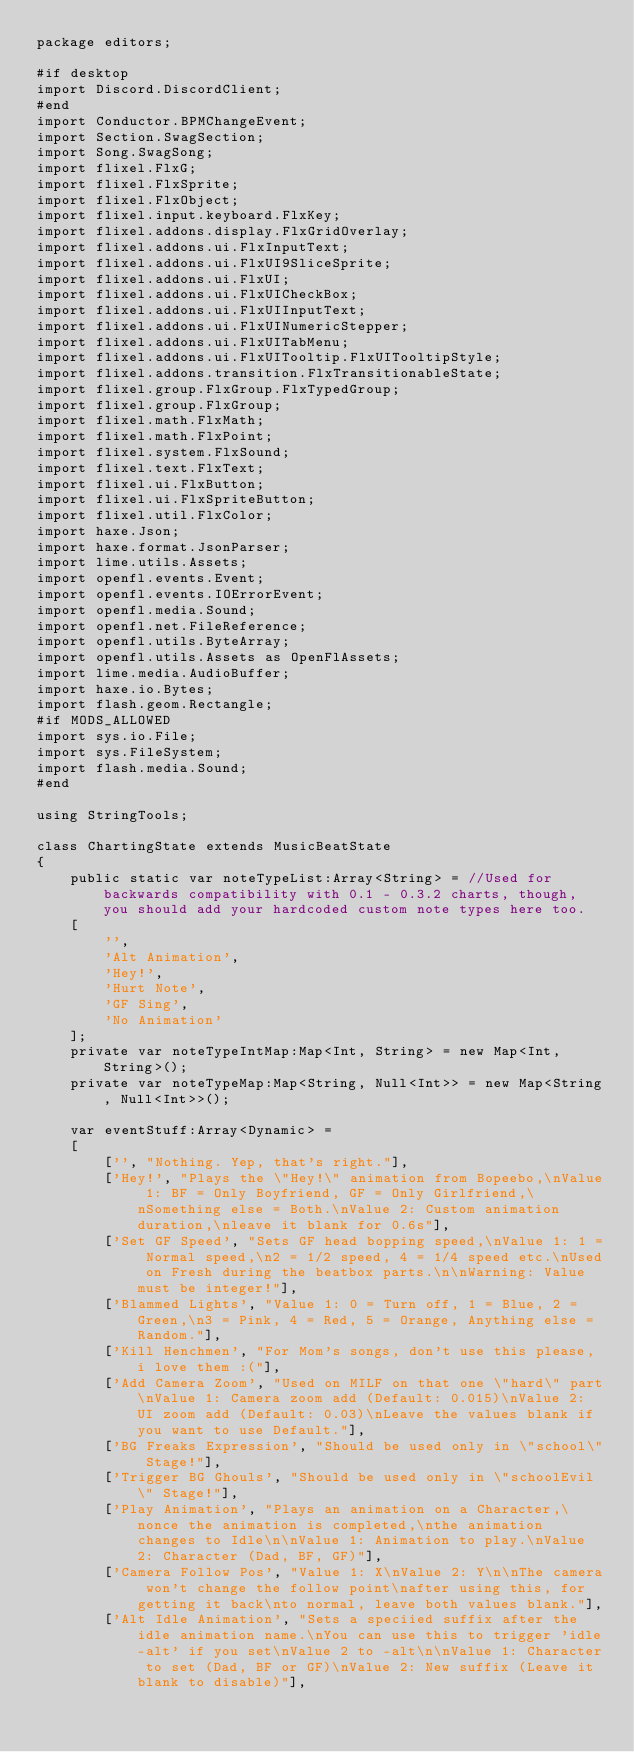<code> <loc_0><loc_0><loc_500><loc_500><_Haxe_>package editors;

#if desktop
import Discord.DiscordClient;
#end
import Conductor.BPMChangeEvent;
import Section.SwagSection;
import Song.SwagSong;
import flixel.FlxG;
import flixel.FlxSprite;
import flixel.FlxObject;
import flixel.input.keyboard.FlxKey;
import flixel.addons.display.FlxGridOverlay;
import flixel.addons.ui.FlxInputText;
import flixel.addons.ui.FlxUI9SliceSprite;
import flixel.addons.ui.FlxUI;
import flixel.addons.ui.FlxUICheckBox;
import flixel.addons.ui.FlxUIInputText;
import flixel.addons.ui.FlxUINumericStepper;
import flixel.addons.ui.FlxUITabMenu;
import flixel.addons.ui.FlxUITooltip.FlxUITooltipStyle;
import flixel.addons.transition.FlxTransitionableState;
import flixel.group.FlxGroup.FlxTypedGroup;
import flixel.group.FlxGroup;
import flixel.math.FlxMath;
import flixel.math.FlxPoint;
import flixel.system.FlxSound;
import flixel.text.FlxText;
import flixel.ui.FlxButton;
import flixel.ui.FlxSpriteButton;
import flixel.util.FlxColor;
import haxe.Json;
import haxe.format.JsonParser;
import lime.utils.Assets;
import openfl.events.Event;
import openfl.events.IOErrorEvent;
import openfl.media.Sound;
import openfl.net.FileReference;
import openfl.utils.ByteArray;
import openfl.utils.Assets as OpenFlAssets;
import lime.media.AudioBuffer;
import haxe.io.Bytes;
import flash.geom.Rectangle;
#if MODS_ALLOWED
import sys.io.File;
import sys.FileSystem;
import flash.media.Sound;
#end

using StringTools;

class ChartingState extends MusicBeatState
{
	public static var noteTypeList:Array<String> = //Used for backwards compatibility with 0.1 - 0.3.2 charts, though, you should add your hardcoded custom note types here too.
	[
		'',
		'Alt Animation',
		'Hey!',
		'Hurt Note',
		'GF Sing',
		'No Animation'
	];
	private var noteTypeIntMap:Map<Int, String> = new Map<Int, String>();
	private var noteTypeMap:Map<String, Null<Int>> = new Map<String, Null<Int>>();

	var eventStuff:Array<Dynamic> =
	[
		['', "Nothing. Yep, that's right."],
		['Hey!', "Plays the \"Hey!\" animation from Bopeebo,\nValue 1: BF = Only Boyfriend, GF = Only Girlfriend,\nSomething else = Both.\nValue 2: Custom animation duration,\nleave it blank for 0.6s"],
		['Set GF Speed', "Sets GF head bopping speed,\nValue 1: 1 = Normal speed,\n2 = 1/2 speed, 4 = 1/4 speed etc.\nUsed on Fresh during the beatbox parts.\n\nWarning: Value must be integer!"],
		['Blammed Lights', "Value 1: 0 = Turn off, 1 = Blue, 2 = Green,\n3 = Pink, 4 = Red, 5 = Orange, Anything else = Random."],
		['Kill Henchmen', "For Mom's songs, don't use this please, i love them :("],
		['Add Camera Zoom', "Used on MILF on that one \"hard\" part\nValue 1: Camera zoom add (Default: 0.015)\nValue 2: UI zoom add (Default: 0.03)\nLeave the values blank if you want to use Default."],
		['BG Freaks Expression', "Should be used only in \"school\" Stage!"],
		['Trigger BG Ghouls', "Should be used only in \"schoolEvil\" Stage!"],
		['Play Animation', "Plays an animation on a Character,\nonce the animation is completed,\nthe animation changes to Idle\n\nValue 1: Animation to play.\nValue 2: Character (Dad, BF, GF)"],
		['Camera Follow Pos', "Value 1: X\nValue 2: Y\n\nThe camera won't change the follow point\nafter using this, for getting it back\nto normal, leave both values blank."],
		['Alt Idle Animation', "Sets a speciied suffix after the idle animation name.\nYou can use this to trigger 'idle-alt' if you set\nValue 2 to -alt\n\nValue 1: Character to set (Dad, BF or GF)\nValue 2: New suffix (Leave it blank to disable)"],</code> 